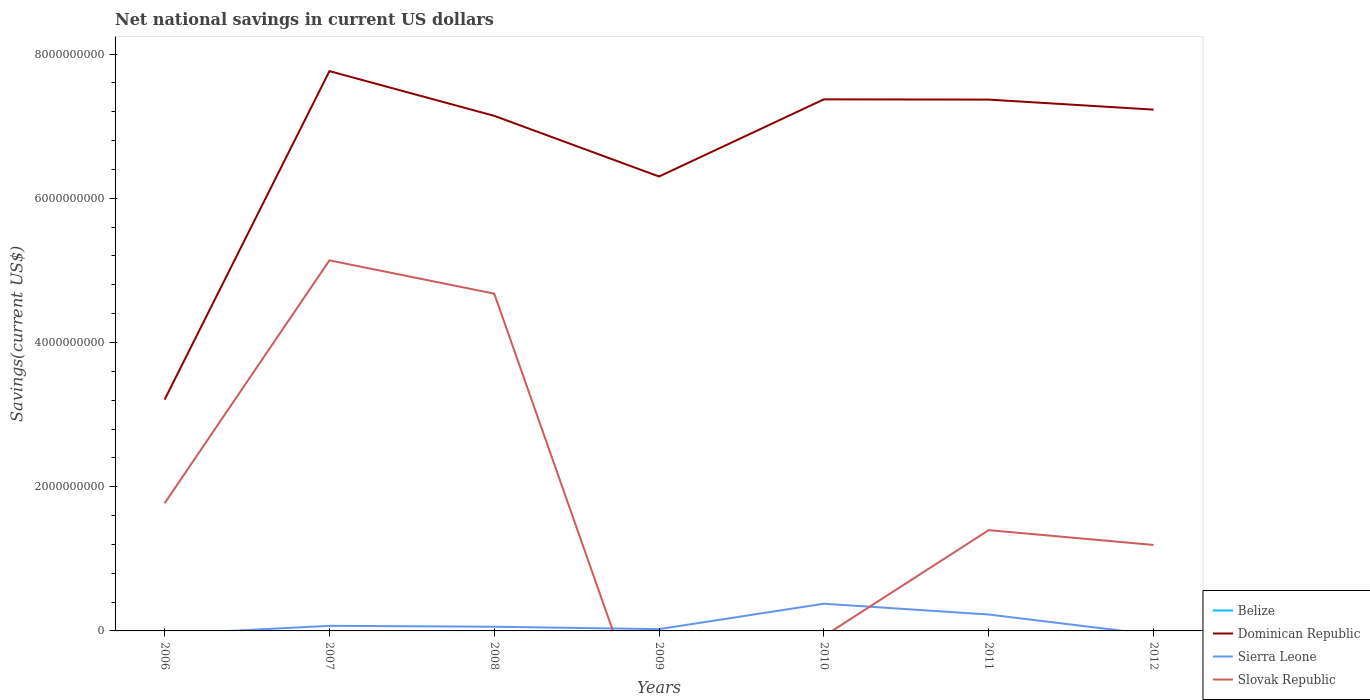Does the line corresponding to Slovak Republic intersect with the line corresponding to Belize?
Ensure brevity in your answer.  Yes. Is the number of lines equal to the number of legend labels?
Your response must be concise. No. Across all years, what is the maximum net national savings in Dominican Republic?
Provide a succinct answer. 3.21e+09. What is the total net national savings in Sierra Leone in the graph?
Provide a succinct answer. -1.70e+08. What is the difference between the highest and the second highest net national savings in Dominican Republic?
Offer a very short reply. 4.56e+09. What is the difference between the highest and the lowest net national savings in Sierra Leone?
Give a very brief answer. 2. Is the net national savings in Dominican Republic strictly greater than the net national savings in Slovak Republic over the years?
Your answer should be very brief. No. How many lines are there?
Ensure brevity in your answer.  3. How many years are there in the graph?
Give a very brief answer. 7. What is the difference between two consecutive major ticks on the Y-axis?
Give a very brief answer. 2.00e+09. Where does the legend appear in the graph?
Provide a succinct answer. Bottom right. How many legend labels are there?
Offer a very short reply. 4. What is the title of the graph?
Your response must be concise. Net national savings in current US dollars. Does "Caribbean small states" appear as one of the legend labels in the graph?
Your answer should be compact. No. What is the label or title of the X-axis?
Keep it short and to the point. Years. What is the label or title of the Y-axis?
Ensure brevity in your answer.  Savings(current US$). What is the Savings(current US$) of Belize in 2006?
Provide a short and direct response. 0. What is the Savings(current US$) in Dominican Republic in 2006?
Provide a succinct answer. 3.21e+09. What is the Savings(current US$) of Sierra Leone in 2006?
Give a very brief answer. 0. What is the Savings(current US$) in Slovak Republic in 2006?
Make the answer very short. 1.77e+09. What is the Savings(current US$) of Belize in 2007?
Offer a very short reply. 0. What is the Savings(current US$) in Dominican Republic in 2007?
Give a very brief answer. 7.76e+09. What is the Savings(current US$) of Sierra Leone in 2007?
Ensure brevity in your answer.  7.09e+07. What is the Savings(current US$) of Slovak Republic in 2007?
Your answer should be compact. 5.14e+09. What is the Savings(current US$) of Belize in 2008?
Your response must be concise. 0. What is the Savings(current US$) of Dominican Republic in 2008?
Make the answer very short. 7.14e+09. What is the Savings(current US$) of Sierra Leone in 2008?
Keep it short and to the point. 5.80e+07. What is the Savings(current US$) of Slovak Republic in 2008?
Give a very brief answer. 4.68e+09. What is the Savings(current US$) of Belize in 2009?
Provide a short and direct response. 0. What is the Savings(current US$) in Dominican Republic in 2009?
Keep it short and to the point. 6.30e+09. What is the Savings(current US$) of Sierra Leone in 2009?
Give a very brief answer. 2.50e+07. What is the Savings(current US$) of Belize in 2010?
Keep it short and to the point. 0. What is the Savings(current US$) of Dominican Republic in 2010?
Your answer should be compact. 7.37e+09. What is the Savings(current US$) in Sierra Leone in 2010?
Your answer should be compact. 3.77e+08. What is the Savings(current US$) of Slovak Republic in 2010?
Offer a terse response. 0. What is the Savings(current US$) in Belize in 2011?
Keep it short and to the point. 0. What is the Savings(current US$) in Dominican Republic in 2011?
Your answer should be very brief. 7.37e+09. What is the Savings(current US$) of Sierra Leone in 2011?
Your answer should be compact. 2.28e+08. What is the Savings(current US$) in Slovak Republic in 2011?
Your answer should be very brief. 1.40e+09. What is the Savings(current US$) of Belize in 2012?
Keep it short and to the point. 0. What is the Savings(current US$) in Dominican Republic in 2012?
Provide a succinct answer. 7.23e+09. What is the Savings(current US$) of Slovak Republic in 2012?
Give a very brief answer. 1.19e+09. Across all years, what is the maximum Savings(current US$) of Dominican Republic?
Offer a very short reply. 7.76e+09. Across all years, what is the maximum Savings(current US$) in Sierra Leone?
Offer a very short reply. 3.77e+08. Across all years, what is the maximum Savings(current US$) in Slovak Republic?
Provide a short and direct response. 5.14e+09. Across all years, what is the minimum Savings(current US$) of Dominican Republic?
Your answer should be very brief. 3.21e+09. Across all years, what is the minimum Savings(current US$) in Slovak Republic?
Give a very brief answer. 0. What is the total Savings(current US$) of Belize in the graph?
Offer a terse response. 0. What is the total Savings(current US$) in Dominican Republic in the graph?
Ensure brevity in your answer.  4.64e+1. What is the total Savings(current US$) of Sierra Leone in the graph?
Offer a terse response. 7.59e+08. What is the total Savings(current US$) of Slovak Republic in the graph?
Provide a succinct answer. 1.42e+1. What is the difference between the Savings(current US$) of Dominican Republic in 2006 and that in 2007?
Provide a succinct answer. -4.56e+09. What is the difference between the Savings(current US$) of Slovak Republic in 2006 and that in 2007?
Offer a terse response. -3.37e+09. What is the difference between the Savings(current US$) of Dominican Republic in 2006 and that in 2008?
Your response must be concise. -3.94e+09. What is the difference between the Savings(current US$) in Slovak Republic in 2006 and that in 2008?
Give a very brief answer. -2.91e+09. What is the difference between the Savings(current US$) in Dominican Republic in 2006 and that in 2009?
Keep it short and to the point. -3.09e+09. What is the difference between the Savings(current US$) of Dominican Republic in 2006 and that in 2010?
Keep it short and to the point. -4.16e+09. What is the difference between the Savings(current US$) in Dominican Republic in 2006 and that in 2011?
Ensure brevity in your answer.  -4.16e+09. What is the difference between the Savings(current US$) in Slovak Republic in 2006 and that in 2011?
Keep it short and to the point. 3.73e+08. What is the difference between the Savings(current US$) of Dominican Republic in 2006 and that in 2012?
Ensure brevity in your answer.  -4.02e+09. What is the difference between the Savings(current US$) of Slovak Republic in 2006 and that in 2012?
Give a very brief answer. 5.79e+08. What is the difference between the Savings(current US$) in Dominican Republic in 2007 and that in 2008?
Provide a succinct answer. 6.20e+08. What is the difference between the Savings(current US$) of Sierra Leone in 2007 and that in 2008?
Your answer should be very brief. 1.29e+07. What is the difference between the Savings(current US$) of Slovak Republic in 2007 and that in 2008?
Offer a terse response. 4.62e+08. What is the difference between the Savings(current US$) of Dominican Republic in 2007 and that in 2009?
Offer a terse response. 1.46e+09. What is the difference between the Savings(current US$) of Sierra Leone in 2007 and that in 2009?
Your response must be concise. 4.59e+07. What is the difference between the Savings(current US$) of Dominican Republic in 2007 and that in 2010?
Your response must be concise. 3.92e+08. What is the difference between the Savings(current US$) in Sierra Leone in 2007 and that in 2010?
Provide a short and direct response. -3.06e+08. What is the difference between the Savings(current US$) in Dominican Republic in 2007 and that in 2011?
Make the answer very short. 3.95e+08. What is the difference between the Savings(current US$) in Sierra Leone in 2007 and that in 2011?
Provide a succinct answer. -1.57e+08. What is the difference between the Savings(current US$) in Slovak Republic in 2007 and that in 2011?
Give a very brief answer. 3.74e+09. What is the difference between the Savings(current US$) of Dominican Republic in 2007 and that in 2012?
Provide a short and direct response. 5.34e+08. What is the difference between the Savings(current US$) of Slovak Republic in 2007 and that in 2012?
Your answer should be compact. 3.95e+09. What is the difference between the Savings(current US$) of Dominican Republic in 2008 and that in 2009?
Offer a terse response. 8.41e+08. What is the difference between the Savings(current US$) in Sierra Leone in 2008 and that in 2009?
Your answer should be compact. 3.30e+07. What is the difference between the Savings(current US$) in Dominican Republic in 2008 and that in 2010?
Provide a succinct answer. -2.29e+08. What is the difference between the Savings(current US$) in Sierra Leone in 2008 and that in 2010?
Your response must be concise. -3.19e+08. What is the difference between the Savings(current US$) in Dominican Republic in 2008 and that in 2011?
Ensure brevity in your answer.  -2.25e+08. What is the difference between the Savings(current US$) in Sierra Leone in 2008 and that in 2011?
Ensure brevity in your answer.  -1.70e+08. What is the difference between the Savings(current US$) in Slovak Republic in 2008 and that in 2011?
Your answer should be very brief. 3.28e+09. What is the difference between the Savings(current US$) of Dominican Republic in 2008 and that in 2012?
Give a very brief answer. -8.63e+07. What is the difference between the Savings(current US$) in Slovak Republic in 2008 and that in 2012?
Ensure brevity in your answer.  3.49e+09. What is the difference between the Savings(current US$) of Dominican Republic in 2009 and that in 2010?
Provide a succinct answer. -1.07e+09. What is the difference between the Savings(current US$) in Sierra Leone in 2009 and that in 2010?
Provide a succinct answer. -3.52e+08. What is the difference between the Savings(current US$) in Dominican Republic in 2009 and that in 2011?
Your answer should be compact. -1.07e+09. What is the difference between the Savings(current US$) of Sierra Leone in 2009 and that in 2011?
Keep it short and to the point. -2.03e+08. What is the difference between the Savings(current US$) of Dominican Republic in 2009 and that in 2012?
Offer a terse response. -9.28e+08. What is the difference between the Savings(current US$) of Dominican Republic in 2010 and that in 2011?
Offer a very short reply. 3.67e+06. What is the difference between the Savings(current US$) of Sierra Leone in 2010 and that in 2011?
Your answer should be compact. 1.50e+08. What is the difference between the Savings(current US$) of Dominican Republic in 2010 and that in 2012?
Your response must be concise. 1.43e+08. What is the difference between the Savings(current US$) in Dominican Republic in 2011 and that in 2012?
Keep it short and to the point. 1.39e+08. What is the difference between the Savings(current US$) of Slovak Republic in 2011 and that in 2012?
Your answer should be compact. 2.05e+08. What is the difference between the Savings(current US$) in Dominican Republic in 2006 and the Savings(current US$) in Sierra Leone in 2007?
Provide a short and direct response. 3.14e+09. What is the difference between the Savings(current US$) in Dominican Republic in 2006 and the Savings(current US$) in Slovak Republic in 2007?
Give a very brief answer. -1.93e+09. What is the difference between the Savings(current US$) of Dominican Republic in 2006 and the Savings(current US$) of Sierra Leone in 2008?
Provide a short and direct response. 3.15e+09. What is the difference between the Savings(current US$) of Dominican Republic in 2006 and the Savings(current US$) of Slovak Republic in 2008?
Offer a terse response. -1.47e+09. What is the difference between the Savings(current US$) of Dominican Republic in 2006 and the Savings(current US$) of Sierra Leone in 2009?
Give a very brief answer. 3.18e+09. What is the difference between the Savings(current US$) in Dominican Republic in 2006 and the Savings(current US$) in Sierra Leone in 2010?
Keep it short and to the point. 2.83e+09. What is the difference between the Savings(current US$) in Dominican Republic in 2006 and the Savings(current US$) in Sierra Leone in 2011?
Give a very brief answer. 2.98e+09. What is the difference between the Savings(current US$) in Dominican Republic in 2006 and the Savings(current US$) in Slovak Republic in 2011?
Keep it short and to the point. 1.81e+09. What is the difference between the Savings(current US$) in Dominican Republic in 2006 and the Savings(current US$) in Slovak Republic in 2012?
Offer a very short reply. 2.02e+09. What is the difference between the Savings(current US$) in Dominican Republic in 2007 and the Savings(current US$) in Sierra Leone in 2008?
Your response must be concise. 7.71e+09. What is the difference between the Savings(current US$) in Dominican Republic in 2007 and the Savings(current US$) in Slovak Republic in 2008?
Your answer should be very brief. 3.09e+09. What is the difference between the Savings(current US$) in Sierra Leone in 2007 and the Savings(current US$) in Slovak Republic in 2008?
Offer a terse response. -4.61e+09. What is the difference between the Savings(current US$) in Dominican Republic in 2007 and the Savings(current US$) in Sierra Leone in 2009?
Ensure brevity in your answer.  7.74e+09. What is the difference between the Savings(current US$) of Dominican Republic in 2007 and the Savings(current US$) of Sierra Leone in 2010?
Provide a succinct answer. 7.39e+09. What is the difference between the Savings(current US$) in Dominican Republic in 2007 and the Savings(current US$) in Sierra Leone in 2011?
Keep it short and to the point. 7.54e+09. What is the difference between the Savings(current US$) of Dominican Republic in 2007 and the Savings(current US$) of Slovak Republic in 2011?
Offer a very short reply. 6.37e+09. What is the difference between the Savings(current US$) of Sierra Leone in 2007 and the Savings(current US$) of Slovak Republic in 2011?
Make the answer very short. -1.33e+09. What is the difference between the Savings(current US$) of Dominican Republic in 2007 and the Savings(current US$) of Slovak Republic in 2012?
Provide a succinct answer. 6.57e+09. What is the difference between the Savings(current US$) of Sierra Leone in 2007 and the Savings(current US$) of Slovak Republic in 2012?
Your response must be concise. -1.12e+09. What is the difference between the Savings(current US$) in Dominican Republic in 2008 and the Savings(current US$) in Sierra Leone in 2009?
Offer a terse response. 7.12e+09. What is the difference between the Savings(current US$) in Dominican Republic in 2008 and the Savings(current US$) in Sierra Leone in 2010?
Provide a succinct answer. 6.77e+09. What is the difference between the Savings(current US$) in Dominican Republic in 2008 and the Savings(current US$) in Sierra Leone in 2011?
Your answer should be very brief. 6.92e+09. What is the difference between the Savings(current US$) in Dominican Republic in 2008 and the Savings(current US$) in Slovak Republic in 2011?
Ensure brevity in your answer.  5.75e+09. What is the difference between the Savings(current US$) in Sierra Leone in 2008 and the Savings(current US$) in Slovak Republic in 2011?
Ensure brevity in your answer.  -1.34e+09. What is the difference between the Savings(current US$) of Dominican Republic in 2008 and the Savings(current US$) of Slovak Republic in 2012?
Keep it short and to the point. 5.95e+09. What is the difference between the Savings(current US$) in Sierra Leone in 2008 and the Savings(current US$) in Slovak Republic in 2012?
Your response must be concise. -1.13e+09. What is the difference between the Savings(current US$) in Dominican Republic in 2009 and the Savings(current US$) in Sierra Leone in 2010?
Your answer should be compact. 5.93e+09. What is the difference between the Savings(current US$) in Dominican Republic in 2009 and the Savings(current US$) in Sierra Leone in 2011?
Make the answer very short. 6.07e+09. What is the difference between the Savings(current US$) of Dominican Republic in 2009 and the Savings(current US$) of Slovak Republic in 2011?
Give a very brief answer. 4.90e+09. What is the difference between the Savings(current US$) of Sierra Leone in 2009 and the Savings(current US$) of Slovak Republic in 2011?
Keep it short and to the point. -1.37e+09. What is the difference between the Savings(current US$) of Dominican Republic in 2009 and the Savings(current US$) of Slovak Republic in 2012?
Your response must be concise. 5.11e+09. What is the difference between the Savings(current US$) of Sierra Leone in 2009 and the Savings(current US$) of Slovak Republic in 2012?
Make the answer very short. -1.17e+09. What is the difference between the Savings(current US$) in Dominican Republic in 2010 and the Savings(current US$) in Sierra Leone in 2011?
Keep it short and to the point. 7.15e+09. What is the difference between the Savings(current US$) in Dominican Republic in 2010 and the Savings(current US$) in Slovak Republic in 2011?
Your response must be concise. 5.97e+09. What is the difference between the Savings(current US$) of Sierra Leone in 2010 and the Savings(current US$) of Slovak Republic in 2011?
Keep it short and to the point. -1.02e+09. What is the difference between the Savings(current US$) in Dominican Republic in 2010 and the Savings(current US$) in Slovak Republic in 2012?
Offer a very short reply. 6.18e+09. What is the difference between the Savings(current US$) in Sierra Leone in 2010 and the Savings(current US$) in Slovak Republic in 2012?
Keep it short and to the point. -8.15e+08. What is the difference between the Savings(current US$) in Dominican Republic in 2011 and the Savings(current US$) in Slovak Republic in 2012?
Your answer should be compact. 6.18e+09. What is the difference between the Savings(current US$) in Sierra Leone in 2011 and the Savings(current US$) in Slovak Republic in 2012?
Offer a very short reply. -9.65e+08. What is the average Savings(current US$) of Belize per year?
Provide a succinct answer. 0. What is the average Savings(current US$) of Dominican Republic per year?
Offer a very short reply. 6.63e+09. What is the average Savings(current US$) of Sierra Leone per year?
Your answer should be compact. 1.08e+08. What is the average Savings(current US$) in Slovak Republic per year?
Your response must be concise. 2.03e+09. In the year 2006, what is the difference between the Savings(current US$) of Dominican Republic and Savings(current US$) of Slovak Republic?
Keep it short and to the point. 1.44e+09. In the year 2007, what is the difference between the Savings(current US$) in Dominican Republic and Savings(current US$) in Sierra Leone?
Make the answer very short. 7.69e+09. In the year 2007, what is the difference between the Savings(current US$) in Dominican Republic and Savings(current US$) in Slovak Republic?
Make the answer very short. 2.62e+09. In the year 2007, what is the difference between the Savings(current US$) of Sierra Leone and Savings(current US$) of Slovak Republic?
Keep it short and to the point. -5.07e+09. In the year 2008, what is the difference between the Savings(current US$) of Dominican Republic and Savings(current US$) of Sierra Leone?
Your answer should be very brief. 7.09e+09. In the year 2008, what is the difference between the Savings(current US$) in Dominican Republic and Savings(current US$) in Slovak Republic?
Your answer should be compact. 2.47e+09. In the year 2008, what is the difference between the Savings(current US$) of Sierra Leone and Savings(current US$) of Slovak Republic?
Offer a terse response. -4.62e+09. In the year 2009, what is the difference between the Savings(current US$) in Dominican Republic and Savings(current US$) in Sierra Leone?
Offer a terse response. 6.28e+09. In the year 2010, what is the difference between the Savings(current US$) in Dominican Republic and Savings(current US$) in Sierra Leone?
Provide a succinct answer. 7.00e+09. In the year 2011, what is the difference between the Savings(current US$) in Dominican Republic and Savings(current US$) in Sierra Leone?
Give a very brief answer. 7.14e+09. In the year 2011, what is the difference between the Savings(current US$) of Dominican Republic and Savings(current US$) of Slovak Republic?
Your response must be concise. 5.97e+09. In the year 2011, what is the difference between the Savings(current US$) of Sierra Leone and Savings(current US$) of Slovak Republic?
Provide a short and direct response. -1.17e+09. In the year 2012, what is the difference between the Savings(current US$) in Dominican Republic and Savings(current US$) in Slovak Republic?
Provide a short and direct response. 6.04e+09. What is the ratio of the Savings(current US$) of Dominican Republic in 2006 to that in 2007?
Offer a very short reply. 0.41. What is the ratio of the Savings(current US$) of Slovak Republic in 2006 to that in 2007?
Your answer should be compact. 0.34. What is the ratio of the Savings(current US$) in Dominican Republic in 2006 to that in 2008?
Make the answer very short. 0.45. What is the ratio of the Savings(current US$) in Slovak Republic in 2006 to that in 2008?
Offer a terse response. 0.38. What is the ratio of the Savings(current US$) of Dominican Republic in 2006 to that in 2009?
Make the answer very short. 0.51. What is the ratio of the Savings(current US$) in Dominican Republic in 2006 to that in 2010?
Your answer should be compact. 0.44. What is the ratio of the Savings(current US$) in Dominican Republic in 2006 to that in 2011?
Provide a short and direct response. 0.44. What is the ratio of the Savings(current US$) of Slovak Republic in 2006 to that in 2011?
Ensure brevity in your answer.  1.27. What is the ratio of the Savings(current US$) of Dominican Republic in 2006 to that in 2012?
Give a very brief answer. 0.44. What is the ratio of the Savings(current US$) of Slovak Republic in 2006 to that in 2012?
Your answer should be very brief. 1.49. What is the ratio of the Savings(current US$) of Dominican Republic in 2007 to that in 2008?
Keep it short and to the point. 1.09. What is the ratio of the Savings(current US$) in Sierra Leone in 2007 to that in 2008?
Give a very brief answer. 1.22. What is the ratio of the Savings(current US$) in Slovak Republic in 2007 to that in 2008?
Provide a succinct answer. 1.1. What is the ratio of the Savings(current US$) in Dominican Republic in 2007 to that in 2009?
Make the answer very short. 1.23. What is the ratio of the Savings(current US$) in Sierra Leone in 2007 to that in 2009?
Ensure brevity in your answer.  2.84. What is the ratio of the Savings(current US$) of Dominican Republic in 2007 to that in 2010?
Keep it short and to the point. 1.05. What is the ratio of the Savings(current US$) in Sierra Leone in 2007 to that in 2010?
Your answer should be compact. 0.19. What is the ratio of the Savings(current US$) in Dominican Republic in 2007 to that in 2011?
Ensure brevity in your answer.  1.05. What is the ratio of the Savings(current US$) in Sierra Leone in 2007 to that in 2011?
Make the answer very short. 0.31. What is the ratio of the Savings(current US$) of Slovak Republic in 2007 to that in 2011?
Your response must be concise. 3.68. What is the ratio of the Savings(current US$) in Dominican Republic in 2007 to that in 2012?
Offer a very short reply. 1.07. What is the ratio of the Savings(current US$) in Slovak Republic in 2007 to that in 2012?
Offer a very short reply. 4.31. What is the ratio of the Savings(current US$) in Dominican Republic in 2008 to that in 2009?
Make the answer very short. 1.13. What is the ratio of the Savings(current US$) in Sierra Leone in 2008 to that in 2009?
Make the answer very short. 2.32. What is the ratio of the Savings(current US$) of Sierra Leone in 2008 to that in 2010?
Your response must be concise. 0.15. What is the ratio of the Savings(current US$) in Dominican Republic in 2008 to that in 2011?
Your response must be concise. 0.97. What is the ratio of the Savings(current US$) of Sierra Leone in 2008 to that in 2011?
Provide a succinct answer. 0.25. What is the ratio of the Savings(current US$) in Slovak Republic in 2008 to that in 2011?
Provide a succinct answer. 3.35. What is the ratio of the Savings(current US$) of Slovak Republic in 2008 to that in 2012?
Offer a terse response. 3.92. What is the ratio of the Savings(current US$) of Dominican Republic in 2009 to that in 2010?
Provide a succinct answer. 0.85. What is the ratio of the Savings(current US$) in Sierra Leone in 2009 to that in 2010?
Provide a short and direct response. 0.07. What is the ratio of the Savings(current US$) in Dominican Republic in 2009 to that in 2011?
Offer a very short reply. 0.86. What is the ratio of the Savings(current US$) in Sierra Leone in 2009 to that in 2011?
Offer a very short reply. 0.11. What is the ratio of the Savings(current US$) in Dominican Republic in 2009 to that in 2012?
Provide a succinct answer. 0.87. What is the ratio of the Savings(current US$) of Sierra Leone in 2010 to that in 2011?
Your response must be concise. 1.66. What is the ratio of the Savings(current US$) in Dominican Republic in 2010 to that in 2012?
Your response must be concise. 1.02. What is the ratio of the Savings(current US$) of Dominican Republic in 2011 to that in 2012?
Your answer should be very brief. 1.02. What is the ratio of the Savings(current US$) in Slovak Republic in 2011 to that in 2012?
Your answer should be compact. 1.17. What is the difference between the highest and the second highest Savings(current US$) of Dominican Republic?
Provide a succinct answer. 3.92e+08. What is the difference between the highest and the second highest Savings(current US$) in Sierra Leone?
Give a very brief answer. 1.50e+08. What is the difference between the highest and the second highest Savings(current US$) in Slovak Republic?
Offer a terse response. 4.62e+08. What is the difference between the highest and the lowest Savings(current US$) of Dominican Republic?
Your answer should be very brief. 4.56e+09. What is the difference between the highest and the lowest Savings(current US$) of Sierra Leone?
Offer a very short reply. 3.77e+08. What is the difference between the highest and the lowest Savings(current US$) in Slovak Republic?
Give a very brief answer. 5.14e+09. 